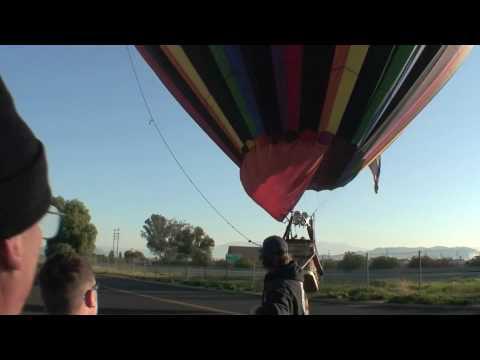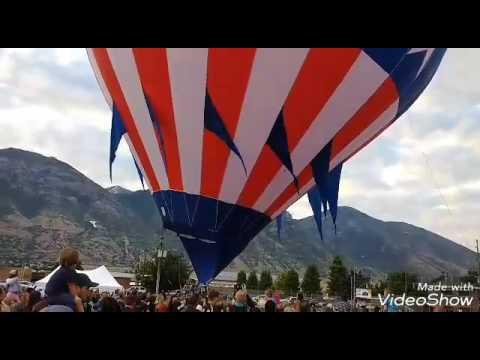The first image is the image on the left, the second image is the image on the right. Assess this claim about the two images: "One image shows a red, white and blue balloon with stripes, and the other shows a multicolored striped balloon with at least six colors.". Correct or not? Answer yes or no. Yes. The first image is the image on the left, the second image is the image on the right. Evaluate the accuracy of this statement regarding the images: "In the left image, there is a single balloon that is red, white and blue.". Is it true? Answer yes or no. Yes. 